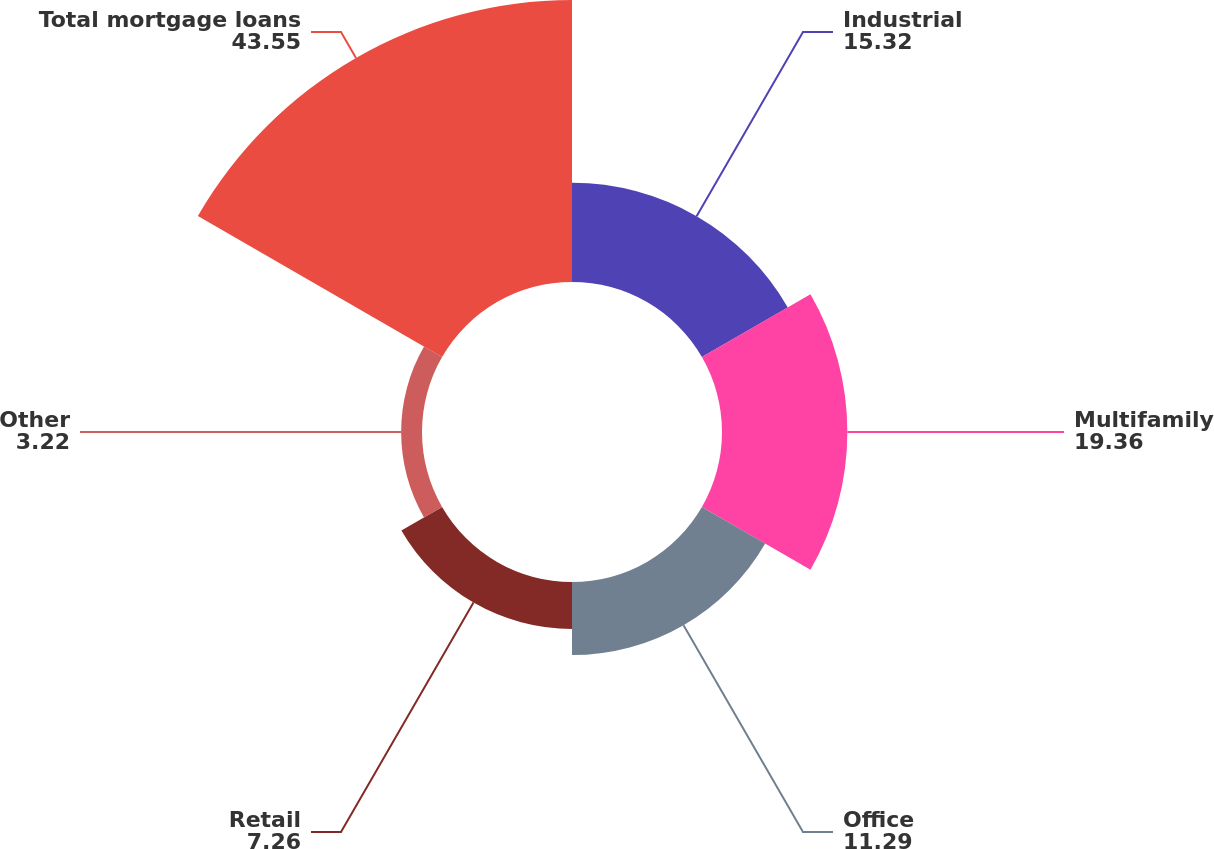<chart> <loc_0><loc_0><loc_500><loc_500><pie_chart><fcel>Industrial<fcel>Multifamily<fcel>Office<fcel>Retail<fcel>Other<fcel>Total mortgage loans<nl><fcel>15.32%<fcel>19.36%<fcel>11.29%<fcel>7.26%<fcel>3.22%<fcel>43.55%<nl></chart> 